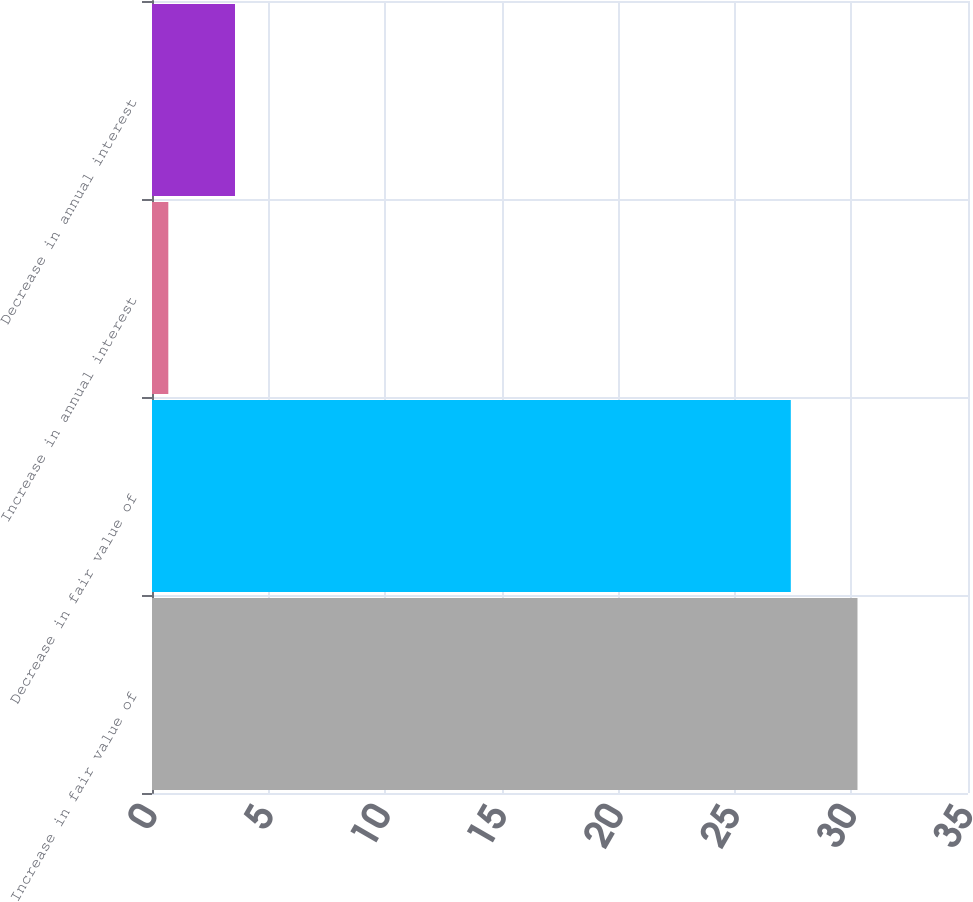<chart> <loc_0><loc_0><loc_500><loc_500><bar_chart><fcel>Increase in fair value of<fcel>Decrease in fair value of<fcel>Increase in annual interest<fcel>Decrease in annual interest<nl><fcel>30.26<fcel>27.4<fcel>0.7<fcel>3.56<nl></chart> 